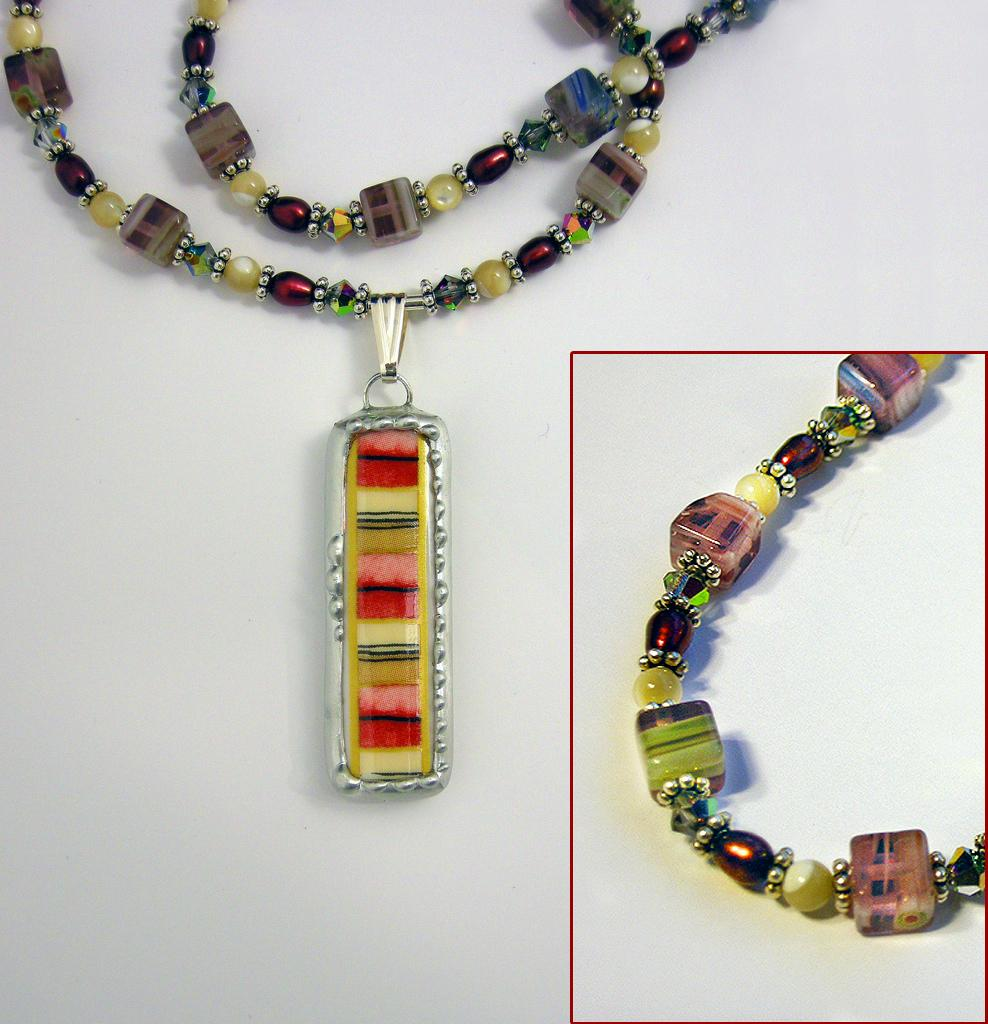What is on the floor in the image? There is a chain on the floor in the image. What can be seen on the right side of the image? There is an image of a chain with beads and pearls on the right side of the image. What feature does the chain on the left side of the image have? The chain on the left side of the image has a pendant. What type of horse can be seen playing basketball in the image? There is no horse or basketball present in the image. 